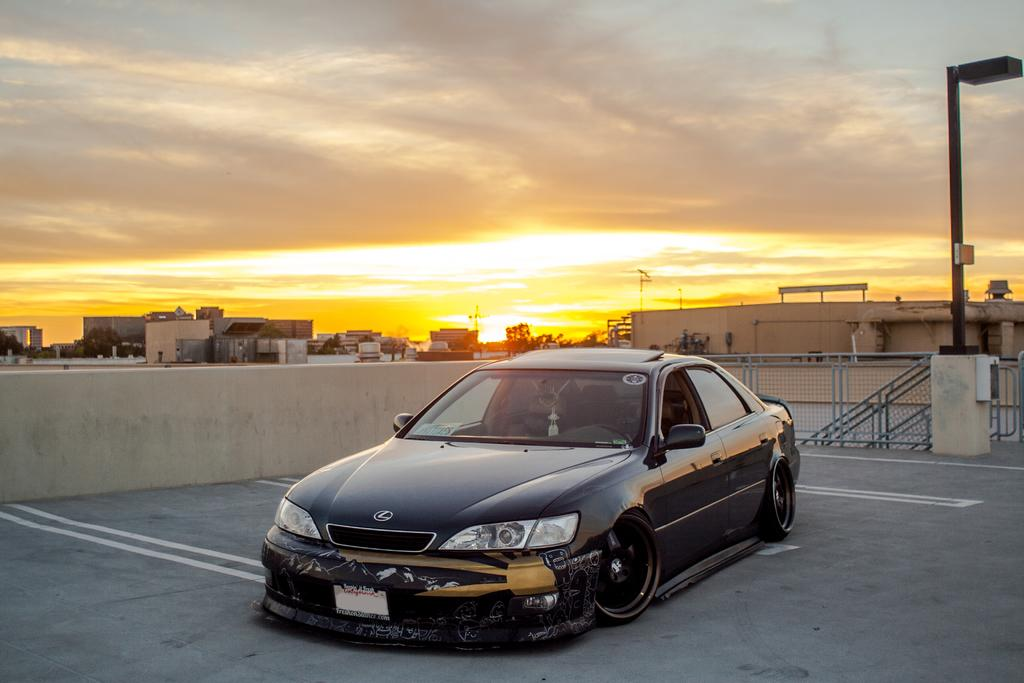What can be seen in the background of the image? The sky is visible in the background of the image. What type of structures are present in the image? There are buildings in the image. What other natural elements can be seen in the image? Trees are present in the image. What man-made objects are visible in the image? Poles and railings are present in the image. Are there any other objects in the image besides the ones mentioned? Yes, there are other objects in the image. What is the main focus of the image? A black car is the main focus of the image. What type of tent can be seen in the image? There is no tent present in the image. What kind of board is being used by the people in the image? There are no people or boards present in the image. 